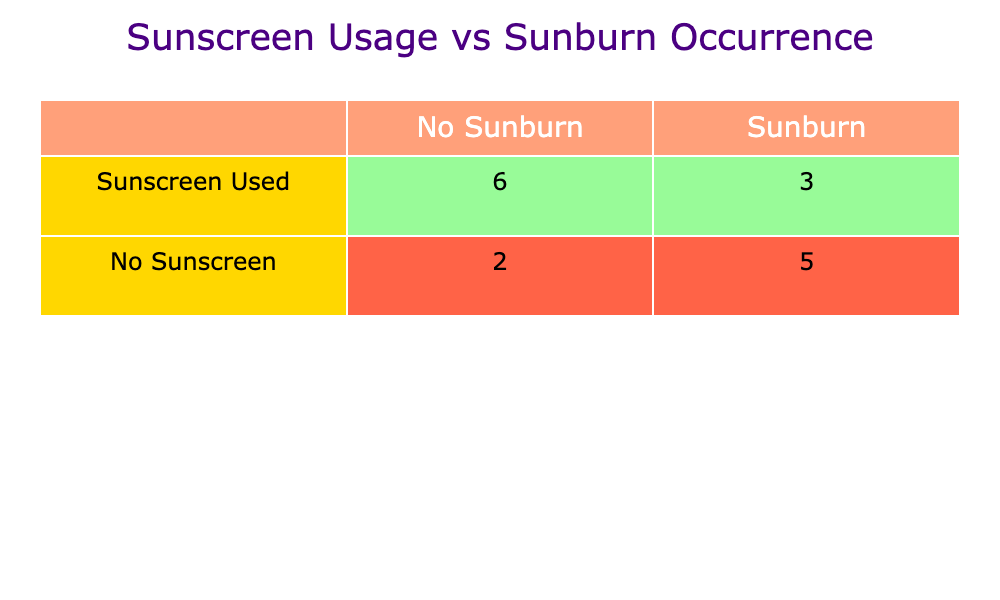What are the true positives in the table? The true positives (TP) represent the count of instances where sunscreen was used and no sunburn occurred. According to the table, the TP value is 3.
Answer: 3 How many individuals experienced sunburn without using sunscreen? The false negatives (FN) indicate those who did not use sunscreen but experienced sunburn. In the table, this count is 4.
Answer: 4 Is it true that everyone who used sunscreen did not get sunburned? This statement is false as there are individuals who used sunscreen but still got sunburned. The table shows there are 2 individuals who experienced sunburn while using sunscreen.
Answer: No What is the total number of individuals who did not experience sunburn? The true negatives (TN) represent those who did not use sunscreen and did not experience sunburn. The table indicates there are 3 individuals in this category.
Answer: 3 How many more individuals sunburned while not using sunscreen compared to those who did use sunscreen? The calculation involves the number of individuals who sunburned without sunscreen (4) minus those who sunburned with sunscreen (2), resulting in a difference of 2.
Answer: 2 What percentage of sunscreen users did not get sunburned? To find this percentage, divide the total number of users who did not get sunburned (3) by the total number of sunscreen users (5), then multiply by 100. This results in a percentage of 60%.
Answer: 60% How many total users applied sunscreen? The count of individuals who used sunscreen can be directly obtained from the table, which shows there are 5 users.
Answer: 5 What do the numbers indicate regarding the effectiveness of sunscreen? The numbers suggest that sunscreen is beneficial as more individuals who used it did not get sunburned compared to those who did not use it. The table indicates 3 individuals with sunscreen had no sunburn versus 3 without sunscreen who did not get burnt.
Answer: It suggests effectiveness 